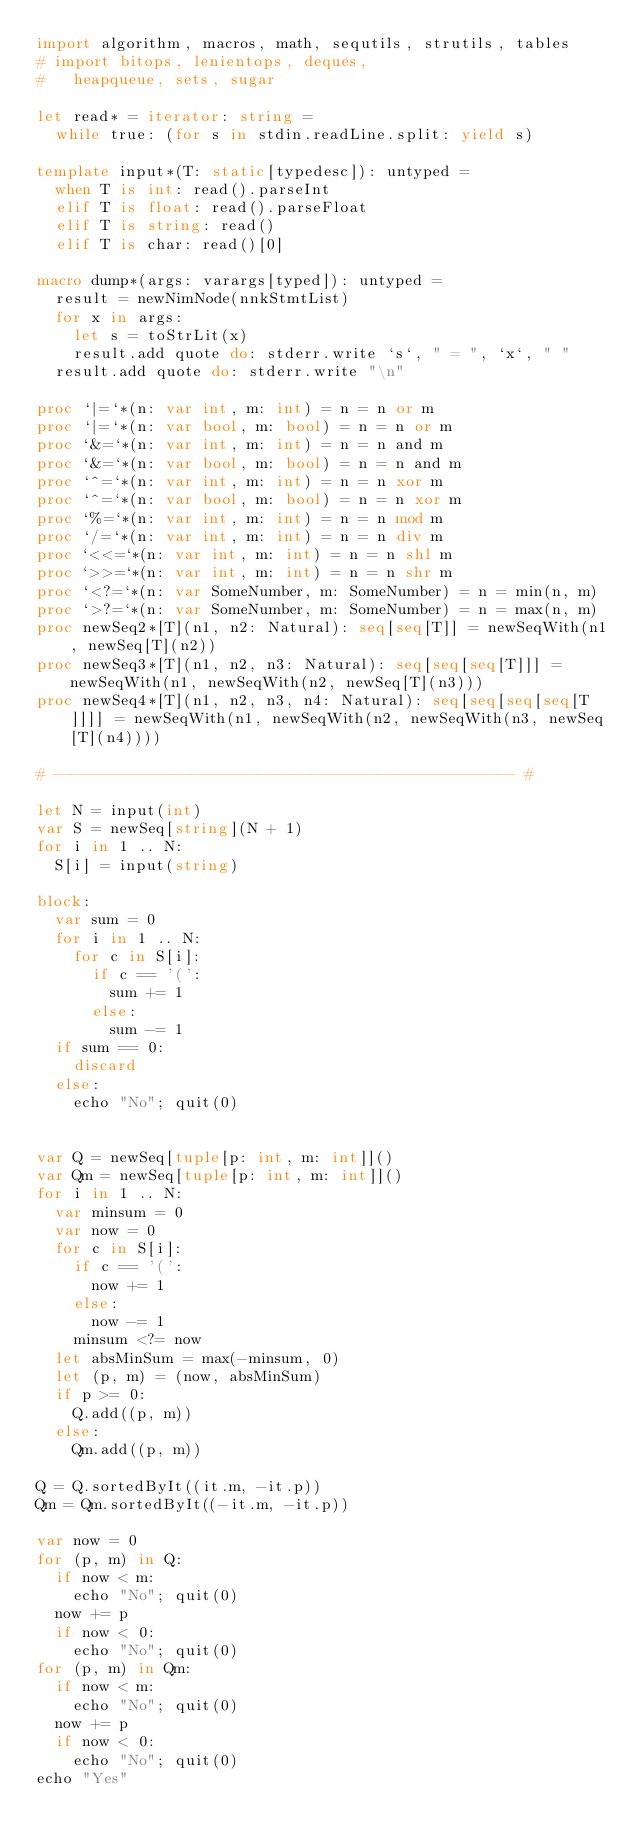Convert code to text. <code><loc_0><loc_0><loc_500><loc_500><_Nim_>import algorithm, macros, math, sequtils, strutils, tables
# import bitops, lenientops, deques,
#   heapqueue, sets, sugar

let read* = iterator: string =
  while true: (for s in stdin.readLine.split: yield s)

template input*(T: static[typedesc]): untyped = 
  when T is int: read().parseInt
  elif T is float: read().parseFloat
  elif T is string: read()
  elif T is char: read()[0]

macro dump*(args: varargs[typed]): untyped =
  result = newNimNode(nnkStmtList)
  for x in args:
    let s = toStrLit(x)
    result.add quote do: stderr.write `s`, " = ", `x`, " "
  result.add quote do: stderr.write "\n"

proc `|=`*(n: var int, m: int) = n = n or m
proc `|=`*(n: var bool, m: bool) = n = n or m
proc `&=`*(n: var int, m: int) = n = n and m
proc `&=`*(n: var bool, m: bool) = n = n and m
proc `^=`*(n: var int, m: int) = n = n xor m
proc `^=`*(n: var bool, m: bool) = n = n xor m
proc `%=`*(n: var int, m: int) = n = n mod m
proc `/=`*(n: var int, m: int) = n = n div m
proc `<<=`*(n: var int, m: int) = n = n shl m
proc `>>=`*(n: var int, m: int) = n = n shr m
proc `<?=`*(n: var SomeNumber, m: SomeNumber) = n = min(n, m)
proc `>?=`*(n: var SomeNumber, m: SomeNumber) = n = max(n, m)
proc newSeq2*[T](n1, n2: Natural): seq[seq[T]] = newSeqWith(n1, newSeq[T](n2))
proc newSeq3*[T](n1, n2, n3: Natural): seq[seq[seq[T]]] = newSeqWith(n1, newSeqWith(n2, newSeq[T](n3)))
proc newSeq4*[T](n1, n2, n3, n4: Natural): seq[seq[seq[seq[T]]]] = newSeqWith(n1, newSeqWith(n2, newSeqWith(n3, newSeq[T](n4))))

# -------------------------------------------------- #

let N = input(int)
var S = newSeq[string](N + 1)
for i in 1 .. N:
  S[i] = input(string)

block:
  var sum = 0
  for i in 1 .. N:
    for c in S[i]:
      if c == '(':
        sum += 1
      else:
        sum -= 1
  if sum == 0:
    discard
  else:
    echo "No"; quit(0)


var Q = newSeq[tuple[p: int, m: int]]()
var Qm = newSeq[tuple[p: int, m: int]]()
for i in 1 .. N:
  var minsum = 0
  var now = 0
  for c in S[i]:
    if c == '(':
      now += 1
    else:
      now -= 1
    minsum <?= now
  let absMinSum = max(-minsum, 0)
  let (p, m) = (now, absMinSum)
  if p >= 0:
    Q.add((p, m))
  else:
    Qm.add((p, m))

Q = Q.sortedByIt((it.m, -it.p))
Qm = Qm.sortedByIt((-it.m, -it.p))

var now = 0
for (p, m) in Q:
  if now < m:
    echo "No"; quit(0)
  now += p
  if now < 0:
    echo "No"; quit(0)
for (p, m) in Qm:
  if now < m:
    echo "No"; quit(0)
  now += p
  if now < 0:
    echo "No"; quit(0)
echo "Yes"</code> 